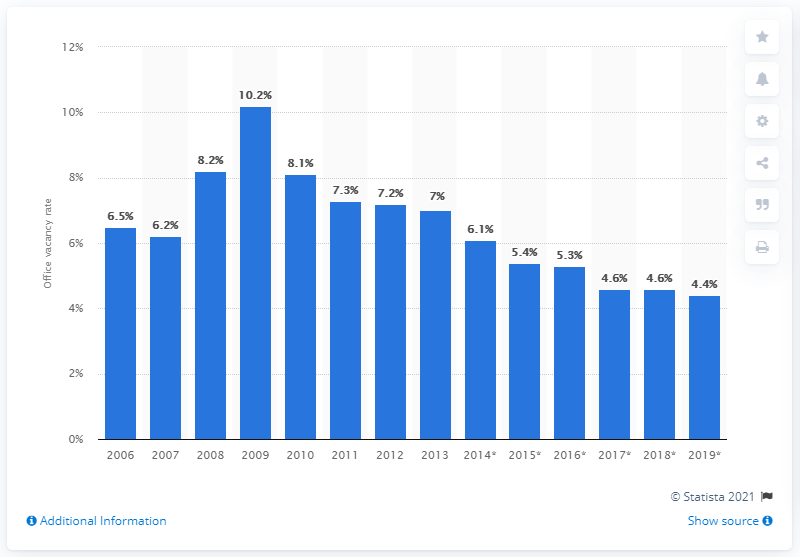Draw attention to some important aspects in this diagram. The estimated vacancy rate for office spaces in London in 2019 was expected to be 4.4%. 